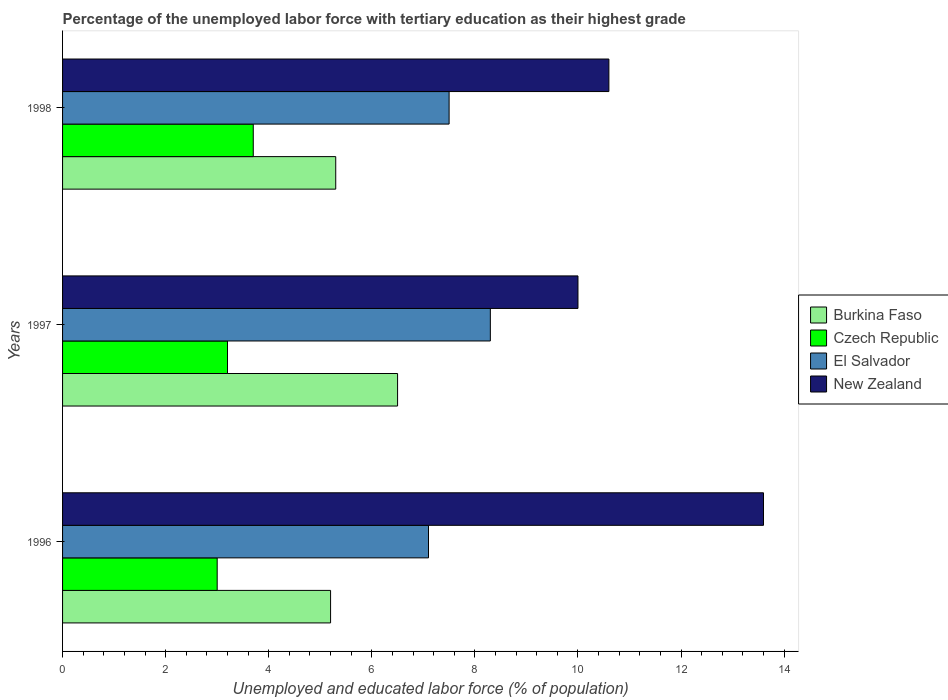How many groups of bars are there?
Offer a very short reply. 3. Are the number of bars on each tick of the Y-axis equal?
Make the answer very short. Yes. What is the label of the 3rd group of bars from the top?
Provide a short and direct response. 1996. What is the percentage of the unemployed labor force with tertiary education in Burkina Faso in 1998?
Your answer should be compact. 5.3. Across all years, what is the maximum percentage of the unemployed labor force with tertiary education in New Zealand?
Ensure brevity in your answer.  13.6. Across all years, what is the minimum percentage of the unemployed labor force with tertiary education in El Salvador?
Offer a very short reply. 7.1. In which year was the percentage of the unemployed labor force with tertiary education in Burkina Faso maximum?
Ensure brevity in your answer.  1997. In which year was the percentage of the unemployed labor force with tertiary education in Czech Republic minimum?
Keep it short and to the point. 1996. What is the total percentage of the unemployed labor force with tertiary education in El Salvador in the graph?
Provide a short and direct response. 22.9. What is the difference between the percentage of the unemployed labor force with tertiary education in Czech Republic in 1996 and that in 1998?
Ensure brevity in your answer.  -0.7. What is the difference between the percentage of the unemployed labor force with tertiary education in Burkina Faso in 1996 and the percentage of the unemployed labor force with tertiary education in El Salvador in 1997?
Your answer should be very brief. -3.1. What is the average percentage of the unemployed labor force with tertiary education in Burkina Faso per year?
Your answer should be very brief. 5.67. In the year 1997, what is the difference between the percentage of the unemployed labor force with tertiary education in New Zealand and percentage of the unemployed labor force with tertiary education in Czech Republic?
Your answer should be compact. 6.8. What is the ratio of the percentage of the unemployed labor force with tertiary education in Burkina Faso in 1996 to that in 1997?
Your answer should be compact. 0.8. Is the percentage of the unemployed labor force with tertiary education in El Salvador in 1997 less than that in 1998?
Provide a short and direct response. No. What is the difference between the highest and the second highest percentage of the unemployed labor force with tertiary education in Burkina Faso?
Offer a terse response. 1.2. What is the difference between the highest and the lowest percentage of the unemployed labor force with tertiary education in Czech Republic?
Provide a short and direct response. 0.7. In how many years, is the percentage of the unemployed labor force with tertiary education in El Salvador greater than the average percentage of the unemployed labor force with tertiary education in El Salvador taken over all years?
Your answer should be very brief. 1. Is the sum of the percentage of the unemployed labor force with tertiary education in New Zealand in 1996 and 1998 greater than the maximum percentage of the unemployed labor force with tertiary education in El Salvador across all years?
Give a very brief answer. Yes. Is it the case that in every year, the sum of the percentage of the unemployed labor force with tertiary education in New Zealand and percentage of the unemployed labor force with tertiary education in Czech Republic is greater than the sum of percentage of the unemployed labor force with tertiary education in Burkina Faso and percentage of the unemployed labor force with tertiary education in El Salvador?
Your answer should be compact. Yes. What does the 3rd bar from the top in 1997 represents?
Your answer should be very brief. Czech Republic. What does the 1st bar from the bottom in 1996 represents?
Your answer should be compact. Burkina Faso. Is it the case that in every year, the sum of the percentage of the unemployed labor force with tertiary education in Burkina Faso and percentage of the unemployed labor force with tertiary education in Czech Republic is greater than the percentage of the unemployed labor force with tertiary education in El Salvador?
Make the answer very short. Yes. Are all the bars in the graph horizontal?
Make the answer very short. Yes. What is the difference between two consecutive major ticks on the X-axis?
Offer a terse response. 2. Does the graph contain any zero values?
Make the answer very short. No. What is the title of the graph?
Provide a short and direct response. Percentage of the unemployed labor force with tertiary education as their highest grade. Does "Brazil" appear as one of the legend labels in the graph?
Your answer should be very brief. No. What is the label or title of the X-axis?
Provide a short and direct response. Unemployed and educated labor force (% of population). What is the label or title of the Y-axis?
Offer a very short reply. Years. What is the Unemployed and educated labor force (% of population) in Burkina Faso in 1996?
Offer a terse response. 5.2. What is the Unemployed and educated labor force (% of population) of Czech Republic in 1996?
Ensure brevity in your answer.  3. What is the Unemployed and educated labor force (% of population) in El Salvador in 1996?
Give a very brief answer. 7.1. What is the Unemployed and educated labor force (% of population) in New Zealand in 1996?
Make the answer very short. 13.6. What is the Unemployed and educated labor force (% of population) in Czech Republic in 1997?
Keep it short and to the point. 3.2. What is the Unemployed and educated labor force (% of population) in El Salvador in 1997?
Give a very brief answer. 8.3. What is the Unemployed and educated labor force (% of population) in Burkina Faso in 1998?
Make the answer very short. 5.3. What is the Unemployed and educated labor force (% of population) in Czech Republic in 1998?
Ensure brevity in your answer.  3.7. What is the Unemployed and educated labor force (% of population) in New Zealand in 1998?
Your answer should be very brief. 10.6. Across all years, what is the maximum Unemployed and educated labor force (% of population) of Burkina Faso?
Keep it short and to the point. 6.5. Across all years, what is the maximum Unemployed and educated labor force (% of population) of Czech Republic?
Give a very brief answer. 3.7. Across all years, what is the maximum Unemployed and educated labor force (% of population) in El Salvador?
Keep it short and to the point. 8.3. Across all years, what is the maximum Unemployed and educated labor force (% of population) of New Zealand?
Keep it short and to the point. 13.6. Across all years, what is the minimum Unemployed and educated labor force (% of population) in Burkina Faso?
Offer a terse response. 5.2. Across all years, what is the minimum Unemployed and educated labor force (% of population) in El Salvador?
Offer a very short reply. 7.1. What is the total Unemployed and educated labor force (% of population) in Burkina Faso in the graph?
Your answer should be very brief. 17. What is the total Unemployed and educated labor force (% of population) of El Salvador in the graph?
Offer a terse response. 22.9. What is the total Unemployed and educated labor force (% of population) in New Zealand in the graph?
Give a very brief answer. 34.2. What is the difference between the Unemployed and educated labor force (% of population) of Burkina Faso in 1996 and that in 1997?
Your answer should be compact. -1.3. What is the difference between the Unemployed and educated labor force (% of population) of El Salvador in 1996 and that in 1997?
Give a very brief answer. -1.2. What is the difference between the Unemployed and educated labor force (% of population) of New Zealand in 1996 and that in 1997?
Offer a very short reply. 3.6. What is the difference between the Unemployed and educated labor force (% of population) of Burkina Faso in 1996 and that in 1998?
Offer a very short reply. -0.1. What is the difference between the Unemployed and educated labor force (% of population) of Czech Republic in 1996 and that in 1998?
Make the answer very short. -0.7. What is the difference between the Unemployed and educated labor force (% of population) of Czech Republic in 1997 and that in 1998?
Make the answer very short. -0.5. What is the difference between the Unemployed and educated labor force (% of population) of El Salvador in 1997 and that in 1998?
Your response must be concise. 0.8. What is the difference between the Unemployed and educated labor force (% of population) in New Zealand in 1997 and that in 1998?
Your response must be concise. -0.6. What is the difference between the Unemployed and educated labor force (% of population) of Burkina Faso in 1996 and the Unemployed and educated labor force (% of population) of El Salvador in 1997?
Offer a very short reply. -3.1. What is the difference between the Unemployed and educated labor force (% of population) in Czech Republic in 1996 and the Unemployed and educated labor force (% of population) in New Zealand in 1997?
Offer a terse response. -7. What is the difference between the Unemployed and educated labor force (% of population) of Burkina Faso in 1996 and the Unemployed and educated labor force (% of population) of El Salvador in 1998?
Ensure brevity in your answer.  -2.3. What is the difference between the Unemployed and educated labor force (% of population) of Czech Republic in 1996 and the Unemployed and educated labor force (% of population) of El Salvador in 1998?
Give a very brief answer. -4.5. What is the difference between the Unemployed and educated labor force (% of population) in El Salvador in 1996 and the Unemployed and educated labor force (% of population) in New Zealand in 1998?
Ensure brevity in your answer.  -3.5. What is the difference between the Unemployed and educated labor force (% of population) in El Salvador in 1997 and the Unemployed and educated labor force (% of population) in New Zealand in 1998?
Make the answer very short. -2.3. What is the average Unemployed and educated labor force (% of population) in Burkina Faso per year?
Provide a succinct answer. 5.67. What is the average Unemployed and educated labor force (% of population) in El Salvador per year?
Your answer should be compact. 7.63. What is the average Unemployed and educated labor force (% of population) of New Zealand per year?
Provide a short and direct response. 11.4. In the year 1996, what is the difference between the Unemployed and educated labor force (% of population) in Burkina Faso and Unemployed and educated labor force (% of population) in Czech Republic?
Your answer should be compact. 2.2. In the year 1996, what is the difference between the Unemployed and educated labor force (% of population) of Burkina Faso and Unemployed and educated labor force (% of population) of El Salvador?
Make the answer very short. -1.9. In the year 1996, what is the difference between the Unemployed and educated labor force (% of population) in Burkina Faso and Unemployed and educated labor force (% of population) in New Zealand?
Keep it short and to the point. -8.4. In the year 1996, what is the difference between the Unemployed and educated labor force (% of population) in Czech Republic and Unemployed and educated labor force (% of population) in New Zealand?
Your response must be concise. -10.6. In the year 1996, what is the difference between the Unemployed and educated labor force (% of population) in El Salvador and Unemployed and educated labor force (% of population) in New Zealand?
Give a very brief answer. -6.5. In the year 1997, what is the difference between the Unemployed and educated labor force (% of population) in Burkina Faso and Unemployed and educated labor force (% of population) in Czech Republic?
Provide a succinct answer. 3.3. In the year 1997, what is the difference between the Unemployed and educated labor force (% of population) in Czech Republic and Unemployed and educated labor force (% of population) in New Zealand?
Offer a very short reply. -6.8. In the year 1997, what is the difference between the Unemployed and educated labor force (% of population) in El Salvador and Unemployed and educated labor force (% of population) in New Zealand?
Make the answer very short. -1.7. In the year 1998, what is the difference between the Unemployed and educated labor force (% of population) in Burkina Faso and Unemployed and educated labor force (% of population) in Czech Republic?
Provide a short and direct response. 1.6. In the year 1998, what is the difference between the Unemployed and educated labor force (% of population) in Burkina Faso and Unemployed and educated labor force (% of population) in El Salvador?
Make the answer very short. -2.2. In the year 1998, what is the difference between the Unemployed and educated labor force (% of population) of Czech Republic and Unemployed and educated labor force (% of population) of El Salvador?
Keep it short and to the point. -3.8. In the year 1998, what is the difference between the Unemployed and educated labor force (% of population) of El Salvador and Unemployed and educated labor force (% of population) of New Zealand?
Your response must be concise. -3.1. What is the ratio of the Unemployed and educated labor force (% of population) of Czech Republic in 1996 to that in 1997?
Your answer should be compact. 0.94. What is the ratio of the Unemployed and educated labor force (% of population) in El Salvador in 1996 to that in 1997?
Provide a short and direct response. 0.86. What is the ratio of the Unemployed and educated labor force (% of population) in New Zealand in 1996 to that in 1997?
Offer a terse response. 1.36. What is the ratio of the Unemployed and educated labor force (% of population) of Burkina Faso in 1996 to that in 1998?
Provide a short and direct response. 0.98. What is the ratio of the Unemployed and educated labor force (% of population) of Czech Republic in 1996 to that in 1998?
Ensure brevity in your answer.  0.81. What is the ratio of the Unemployed and educated labor force (% of population) of El Salvador in 1996 to that in 1998?
Keep it short and to the point. 0.95. What is the ratio of the Unemployed and educated labor force (% of population) of New Zealand in 1996 to that in 1998?
Ensure brevity in your answer.  1.28. What is the ratio of the Unemployed and educated labor force (% of population) in Burkina Faso in 1997 to that in 1998?
Your answer should be very brief. 1.23. What is the ratio of the Unemployed and educated labor force (% of population) in Czech Republic in 1997 to that in 1998?
Your answer should be very brief. 0.86. What is the ratio of the Unemployed and educated labor force (% of population) in El Salvador in 1997 to that in 1998?
Provide a succinct answer. 1.11. What is the ratio of the Unemployed and educated labor force (% of population) of New Zealand in 1997 to that in 1998?
Keep it short and to the point. 0.94. What is the difference between the highest and the second highest Unemployed and educated labor force (% of population) of Burkina Faso?
Your response must be concise. 1.2. What is the difference between the highest and the second highest Unemployed and educated labor force (% of population) in Czech Republic?
Your answer should be compact. 0.5. What is the difference between the highest and the second highest Unemployed and educated labor force (% of population) in El Salvador?
Ensure brevity in your answer.  0.8. 